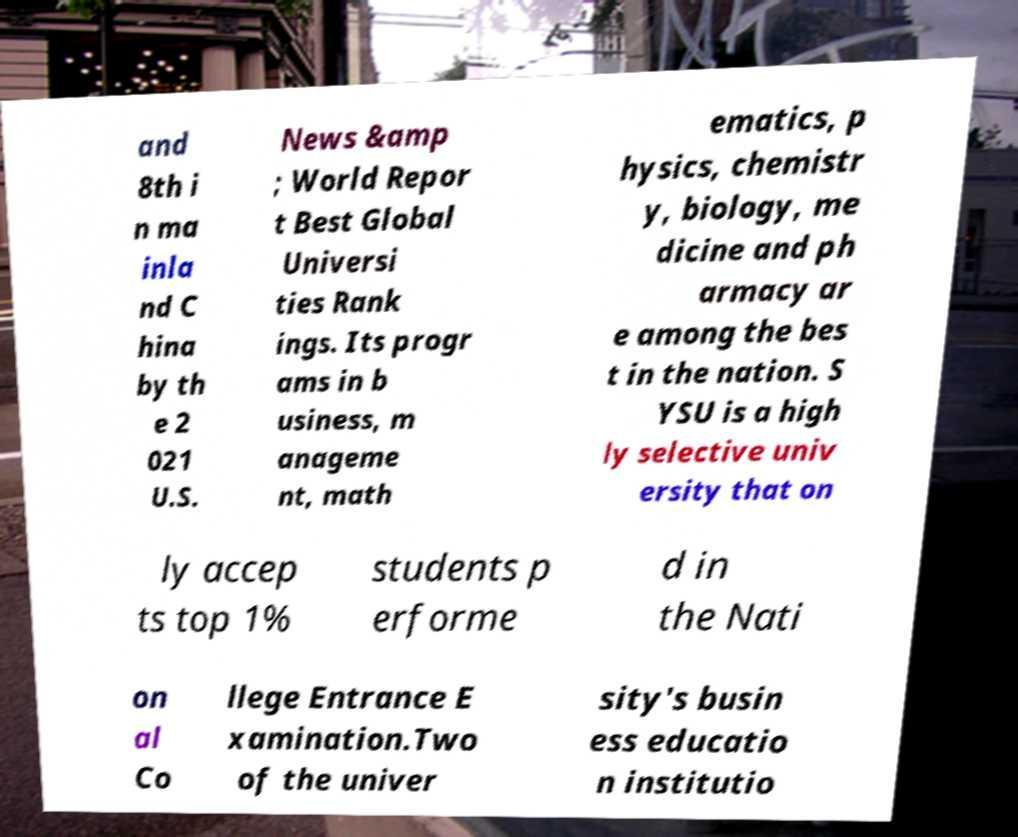Please read and relay the text visible in this image. What does it say? and 8th i n ma inla nd C hina by th e 2 021 U.S. News &amp ; World Repor t Best Global Universi ties Rank ings. Its progr ams in b usiness, m anageme nt, math ematics, p hysics, chemistr y, biology, me dicine and ph armacy ar e among the bes t in the nation. S YSU is a high ly selective univ ersity that on ly accep ts top 1% students p erforme d in the Nati on al Co llege Entrance E xamination.Two of the univer sity's busin ess educatio n institutio 